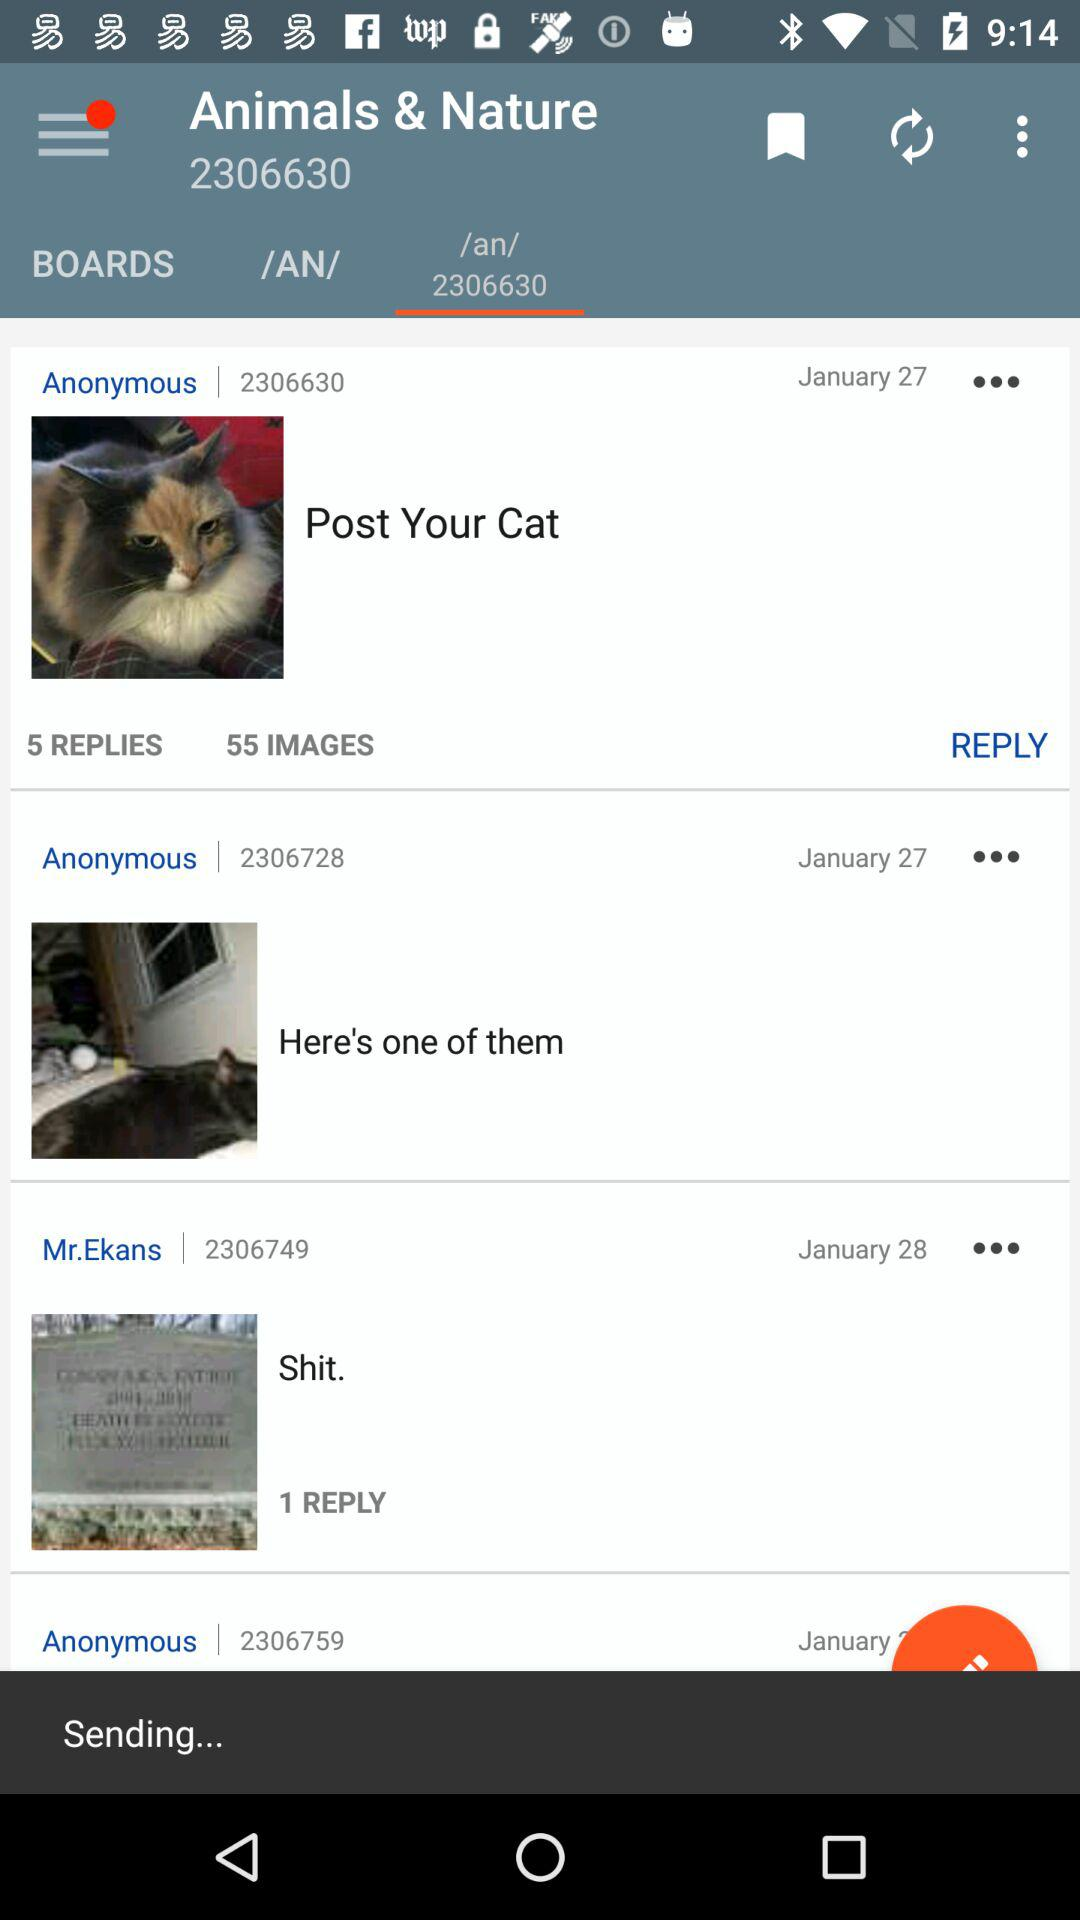How many replies are there for "Post Your Cat"? There are 5 replies for "Post Your Cat". 